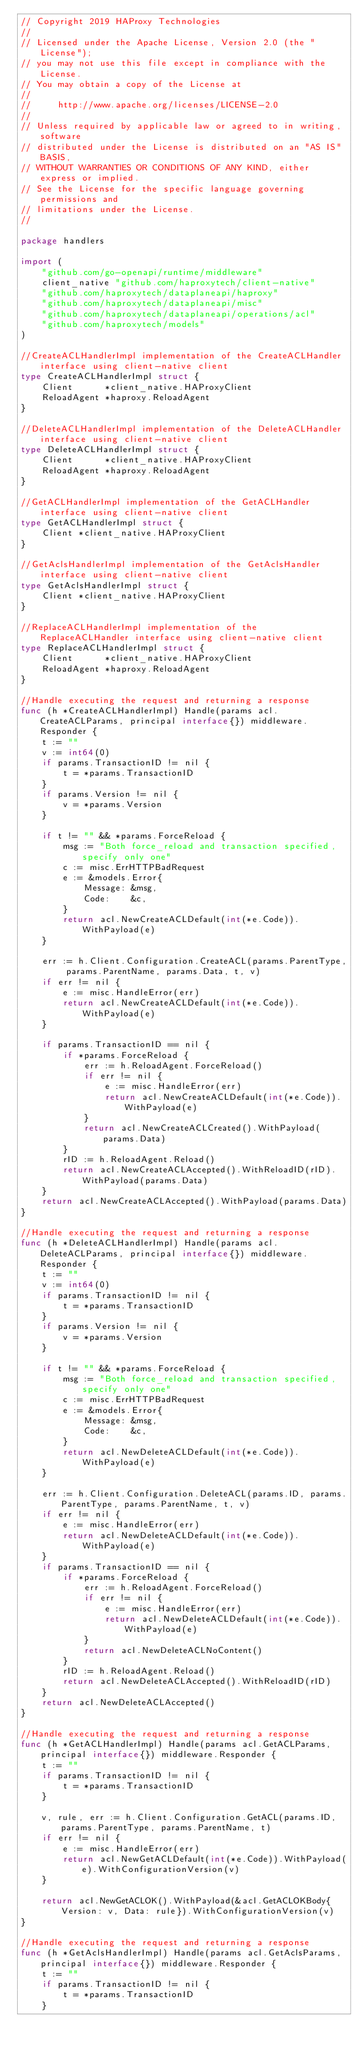Convert code to text. <code><loc_0><loc_0><loc_500><loc_500><_Go_>// Copyright 2019 HAProxy Technologies
//
// Licensed under the Apache License, Version 2.0 (the "License");
// you may not use this file except in compliance with the License.
// You may obtain a copy of the License at
//
//     http://www.apache.org/licenses/LICENSE-2.0
//
// Unless required by applicable law or agreed to in writing, software
// distributed under the License is distributed on an "AS IS" BASIS,
// WITHOUT WARRANTIES OR CONDITIONS OF ANY KIND, either express or implied.
// See the License for the specific language governing permissions and
// limitations under the License.
//

package handlers

import (
	"github.com/go-openapi/runtime/middleware"
	client_native "github.com/haproxytech/client-native"
	"github.com/haproxytech/dataplaneapi/haproxy"
	"github.com/haproxytech/dataplaneapi/misc"
	"github.com/haproxytech/dataplaneapi/operations/acl"
	"github.com/haproxytech/models"
)

//CreateACLHandlerImpl implementation of the CreateACLHandler interface using client-native client
type CreateACLHandlerImpl struct {
	Client      *client_native.HAProxyClient
	ReloadAgent *haproxy.ReloadAgent
}

//DeleteACLHandlerImpl implementation of the DeleteACLHandler interface using client-native client
type DeleteACLHandlerImpl struct {
	Client      *client_native.HAProxyClient
	ReloadAgent *haproxy.ReloadAgent
}

//GetACLHandlerImpl implementation of the GetACLHandler interface using client-native client
type GetACLHandlerImpl struct {
	Client *client_native.HAProxyClient
}

//GetAclsHandlerImpl implementation of the GetAclsHandler interface using client-native client
type GetAclsHandlerImpl struct {
	Client *client_native.HAProxyClient
}

//ReplaceACLHandlerImpl implementation of the ReplaceACLHandler interface using client-native client
type ReplaceACLHandlerImpl struct {
	Client      *client_native.HAProxyClient
	ReloadAgent *haproxy.ReloadAgent
}

//Handle executing the request and returning a response
func (h *CreateACLHandlerImpl) Handle(params acl.CreateACLParams, principal interface{}) middleware.Responder {
	t := ""
	v := int64(0)
	if params.TransactionID != nil {
		t = *params.TransactionID
	}
	if params.Version != nil {
		v = *params.Version
	}

	if t != "" && *params.ForceReload {
		msg := "Both force_reload and transaction specified, specify only one"
		c := misc.ErrHTTPBadRequest
		e := &models.Error{
			Message: &msg,
			Code:    &c,
		}
		return acl.NewCreateACLDefault(int(*e.Code)).WithPayload(e)
	}

	err := h.Client.Configuration.CreateACL(params.ParentType, params.ParentName, params.Data, t, v)
	if err != nil {
		e := misc.HandleError(err)
		return acl.NewCreateACLDefault(int(*e.Code)).WithPayload(e)
	}

	if params.TransactionID == nil {
		if *params.ForceReload {
			err := h.ReloadAgent.ForceReload()
			if err != nil {
				e := misc.HandleError(err)
				return acl.NewCreateACLDefault(int(*e.Code)).WithPayload(e)
			}
			return acl.NewCreateACLCreated().WithPayload(params.Data)
		}
		rID := h.ReloadAgent.Reload()
		return acl.NewCreateACLAccepted().WithReloadID(rID).WithPayload(params.Data)
	}
	return acl.NewCreateACLAccepted().WithPayload(params.Data)
}

//Handle executing the request and returning a response
func (h *DeleteACLHandlerImpl) Handle(params acl.DeleteACLParams, principal interface{}) middleware.Responder {
	t := ""
	v := int64(0)
	if params.TransactionID != nil {
		t = *params.TransactionID
	}
	if params.Version != nil {
		v = *params.Version
	}

	if t != "" && *params.ForceReload {
		msg := "Both force_reload and transaction specified, specify only one"
		c := misc.ErrHTTPBadRequest
		e := &models.Error{
			Message: &msg,
			Code:    &c,
		}
		return acl.NewDeleteACLDefault(int(*e.Code)).WithPayload(e)
	}

	err := h.Client.Configuration.DeleteACL(params.ID, params.ParentType, params.ParentName, t, v)
	if err != nil {
		e := misc.HandleError(err)
		return acl.NewDeleteACLDefault(int(*e.Code)).WithPayload(e)
	}
	if params.TransactionID == nil {
		if *params.ForceReload {
			err := h.ReloadAgent.ForceReload()
			if err != nil {
				e := misc.HandleError(err)
				return acl.NewDeleteACLDefault(int(*e.Code)).WithPayload(e)
			}
			return acl.NewDeleteACLNoContent()
		}
		rID := h.ReloadAgent.Reload()
		return acl.NewDeleteACLAccepted().WithReloadID(rID)
	}
	return acl.NewDeleteACLAccepted()
}

//Handle executing the request and returning a response
func (h *GetACLHandlerImpl) Handle(params acl.GetACLParams, principal interface{}) middleware.Responder {
	t := ""
	if params.TransactionID != nil {
		t = *params.TransactionID
	}

	v, rule, err := h.Client.Configuration.GetACL(params.ID, params.ParentType, params.ParentName, t)
	if err != nil {
		e := misc.HandleError(err)
		return acl.NewGetACLDefault(int(*e.Code)).WithPayload(e).WithConfigurationVersion(v)
	}

	return acl.NewGetACLOK().WithPayload(&acl.GetACLOKBody{Version: v, Data: rule}).WithConfigurationVersion(v)
}

//Handle executing the request and returning a response
func (h *GetAclsHandlerImpl) Handle(params acl.GetAclsParams, principal interface{}) middleware.Responder {
	t := ""
	if params.TransactionID != nil {
		t = *params.TransactionID
	}
</code> 